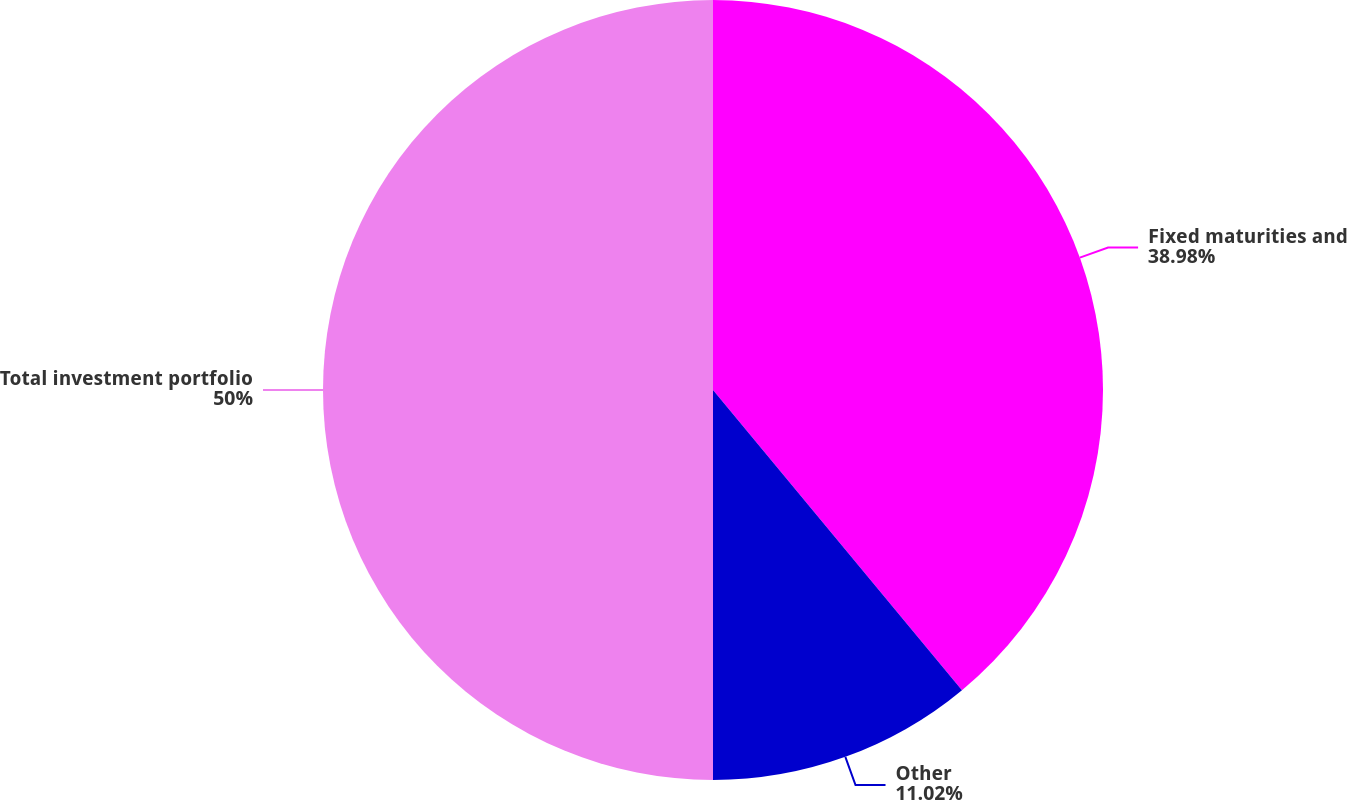Convert chart to OTSL. <chart><loc_0><loc_0><loc_500><loc_500><pie_chart><fcel>Fixed maturities and<fcel>Other<fcel>Total investment portfolio<nl><fcel>38.98%<fcel>11.02%<fcel>50.0%<nl></chart> 